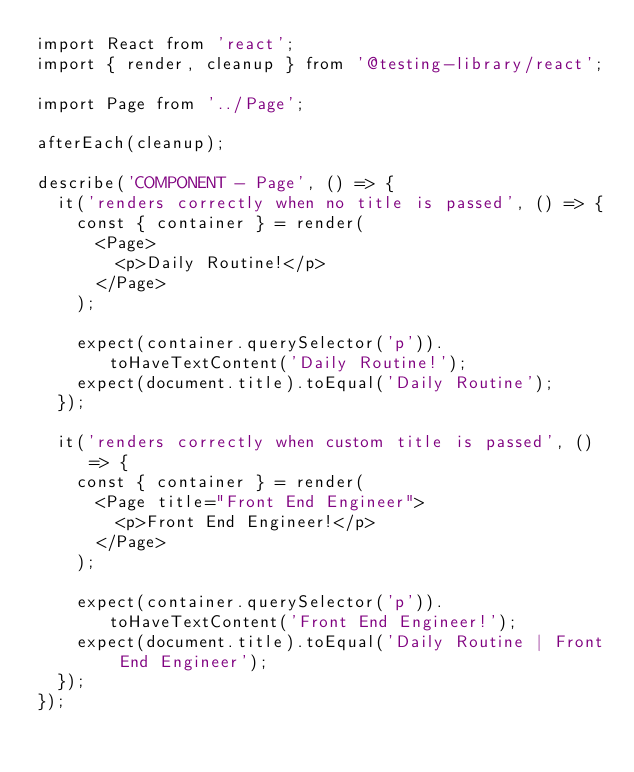Convert code to text. <code><loc_0><loc_0><loc_500><loc_500><_JavaScript_>import React from 'react';
import { render, cleanup } from '@testing-library/react';

import Page from '../Page';

afterEach(cleanup);

describe('COMPONENT - Page', () => {
  it('renders correctly when no title is passed', () => {
    const { container } = render(
      <Page>
        <p>Daily Routine!</p>
      </Page>
    );

    expect(container.querySelector('p')).toHaveTextContent('Daily Routine!');
    expect(document.title).toEqual('Daily Routine');
  });

  it('renders correctly when custom title is passed', () => {
    const { container } = render(
      <Page title="Front End Engineer">
        <p>Front End Engineer!</p>
      </Page>
    );

    expect(container.querySelector('p')).toHaveTextContent('Front End Engineer!');
    expect(document.title).toEqual('Daily Routine | Front End Engineer');
  });
});
</code> 